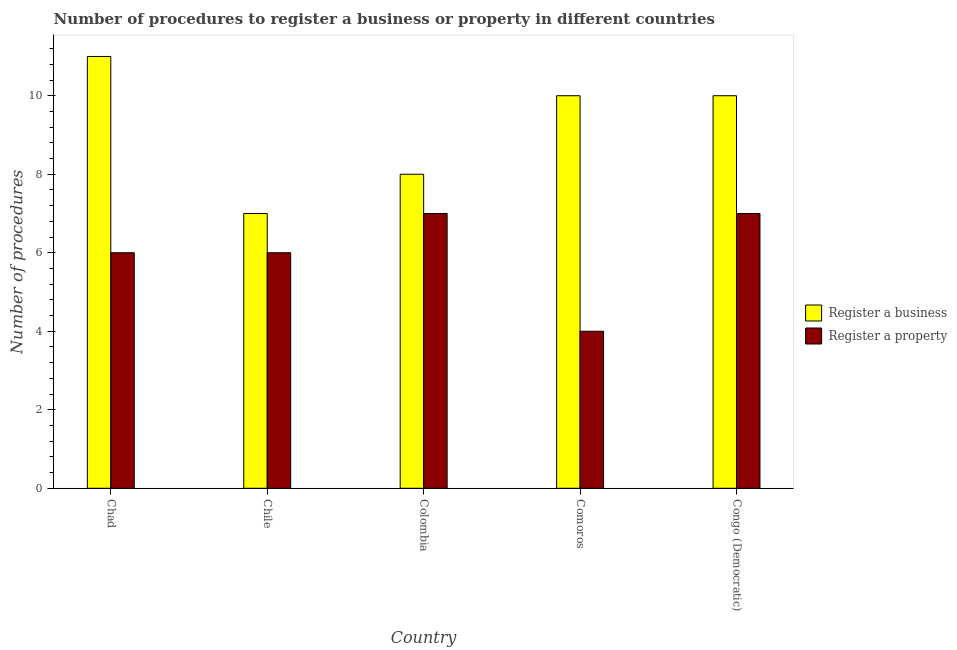How many different coloured bars are there?
Your answer should be very brief. 2. Are the number of bars per tick equal to the number of legend labels?
Your answer should be very brief. Yes. What is the label of the 4th group of bars from the left?
Give a very brief answer. Comoros. What is the number of procedures to register a property in Colombia?
Provide a short and direct response. 7. In which country was the number of procedures to register a business maximum?
Provide a short and direct response. Chad. What is the total number of procedures to register a business in the graph?
Offer a terse response. 46. In how many countries, is the number of procedures to register a business greater than 6.8 ?
Give a very brief answer. 5. What is the ratio of the number of procedures to register a property in Comoros to that in Congo (Democratic)?
Offer a very short reply. 0.57. Is the number of procedures to register a property in Chad less than that in Chile?
Keep it short and to the point. No. Is the difference between the number of procedures to register a business in Chad and Congo (Democratic) greater than the difference between the number of procedures to register a property in Chad and Congo (Democratic)?
Keep it short and to the point. Yes. What is the difference between the highest and the second highest number of procedures to register a business?
Ensure brevity in your answer.  1. What is the difference between the highest and the lowest number of procedures to register a property?
Your response must be concise. 3. What does the 2nd bar from the left in Colombia represents?
Provide a succinct answer. Register a property. What does the 2nd bar from the right in Chile represents?
Ensure brevity in your answer.  Register a business. How many bars are there?
Offer a terse response. 10. Are all the bars in the graph horizontal?
Provide a short and direct response. No. What is the difference between two consecutive major ticks on the Y-axis?
Provide a short and direct response. 2. Does the graph contain any zero values?
Provide a short and direct response. No. Where does the legend appear in the graph?
Keep it short and to the point. Center right. What is the title of the graph?
Your response must be concise. Number of procedures to register a business or property in different countries. Does "Registered firms" appear as one of the legend labels in the graph?
Your answer should be very brief. No. What is the label or title of the X-axis?
Offer a very short reply. Country. What is the label or title of the Y-axis?
Provide a succinct answer. Number of procedures. What is the Number of procedures of Register a business in Colombia?
Give a very brief answer. 8. What is the Number of procedures in Register a property in Colombia?
Ensure brevity in your answer.  7. What is the Number of procedures of Register a business in Comoros?
Make the answer very short. 10. What is the Number of procedures of Register a property in Comoros?
Your answer should be compact. 4. What is the Number of procedures of Register a property in Congo (Democratic)?
Offer a terse response. 7. Across all countries, what is the maximum Number of procedures in Register a business?
Offer a very short reply. 11. Across all countries, what is the maximum Number of procedures of Register a property?
Ensure brevity in your answer.  7. Across all countries, what is the minimum Number of procedures in Register a business?
Ensure brevity in your answer.  7. Across all countries, what is the minimum Number of procedures in Register a property?
Your answer should be compact. 4. What is the total Number of procedures of Register a business in the graph?
Your answer should be very brief. 46. What is the difference between the Number of procedures in Register a property in Chad and that in Chile?
Ensure brevity in your answer.  0. What is the difference between the Number of procedures in Register a property in Chad and that in Comoros?
Provide a succinct answer. 2. What is the difference between the Number of procedures of Register a business in Chad and that in Congo (Democratic)?
Your answer should be compact. 1. What is the difference between the Number of procedures of Register a property in Chad and that in Congo (Democratic)?
Provide a short and direct response. -1. What is the difference between the Number of procedures of Register a business in Chile and that in Comoros?
Provide a succinct answer. -3. What is the difference between the Number of procedures of Register a property in Chile and that in Comoros?
Give a very brief answer. 2. What is the difference between the Number of procedures in Register a business in Chile and that in Congo (Democratic)?
Offer a terse response. -3. What is the difference between the Number of procedures in Register a business in Colombia and that in Comoros?
Give a very brief answer. -2. What is the difference between the Number of procedures in Register a business in Colombia and that in Congo (Democratic)?
Provide a short and direct response. -2. What is the difference between the Number of procedures in Register a property in Colombia and that in Congo (Democratic)?
Keep it short and to the point. 0. What is the difference between the Number of procedures in Register a business in Comoros and that in Congo (Democratic)?
Make the answer very short. 0. What is the difference between the Number of procedures of Register a business in Chad and the Number of procedures of Register a property in Colombia?
Offer a terse response. 4. What is the difference between the Number of procedures of Register a business in Chad and the Number of procedures of Register a property in Congo (Democratic)?
Ensure brevity in your answer.  4. What is the difference between the Number of procedures of Register a business in Chile and the Number of procedures of Register a property in Colombia?
Your response must be concise. 0. What is the difference between the Number of procedures of Register a business in Chile and the Number of procedures of Register a property in Comoros?
Your answer should be very brief. 3. What is the difference between the Number of procedures in Register a business in Colombia and the Number of procedures in Register a property in Comoros?
Give a very brief answer. 4. What is the difference between the Number of procedures of Register a business in Colombia and the Number of procedures of Register a property in Congo (Democratic)?
Keep it short and to the point. 1. What is the average Number of procedures of Register a business per country?
Give a very brief answer. 9.2. What is the difference between the Number of procedures in Register a business and Number of procedures in Register a property in Chile?
Offer a terse response. 1. What is the difference between the Number of procedures in Register a business and Number of procedures in Register a property in Colombia?
Keep it short and to the point. 1. What is the difference between the Number of procedures of Register a business and Number of procedures of Register a property in Congo (Democratic)?
Your response must be concise. 3. What is the ratio of the Number of procedures in Register a business in Chad to that in Chile?
Offer a very short reply. 1.57. What is the ratio of the Number of procedures in Register a property in Chad to that in Chile?
Provide a succinct answer. 1. What is the ratio of the Number of procedures in Register a business in Chad to that in Colombia?
Provide a succinct answer. 1.38. What is the ratio of the Number of procedures of Register a property in Chad to that in Colombia?
Make the answer very short. 0.86. What is the ratio of the Number of procedures of Register a business in Chad to that in Comoros?
Keep it short and to the point. 1.1. What is the ratio of the Number of procedures in Register a business in Chad to that in Congo (Democratic)?
Your response must be concise. 1.1. What is the ratio of the Number of procedures in Register a business in Chile to that in Comoros?
Your answer should be compact. 0.7. What is the ratio of the Number of procedures in Register a business in Chile to that in Congo (Democratic)?
Make the answer very short. 0.7. What is the ratio of the Number of procedures in Register a property in Chile to that in Congo (Democratic)?
Your response must be concise. 0.86. What is the ratio of the Number of procedures in Register a business in Colombia to that in Comoros?
Your answer should be very brief. 0.8. What is the ratio of the Number of procedures of Register a property in Colombia to that in Congo (Democratic)?
Your response must be concise. 1. What is the difference between the highest and the second highest Number of procedures of Register a business?
Provide a short and direct response. 1. What is the difference between the highest and the second highest Number of procedures in Register a property?
Offer a very short reply. 0. 